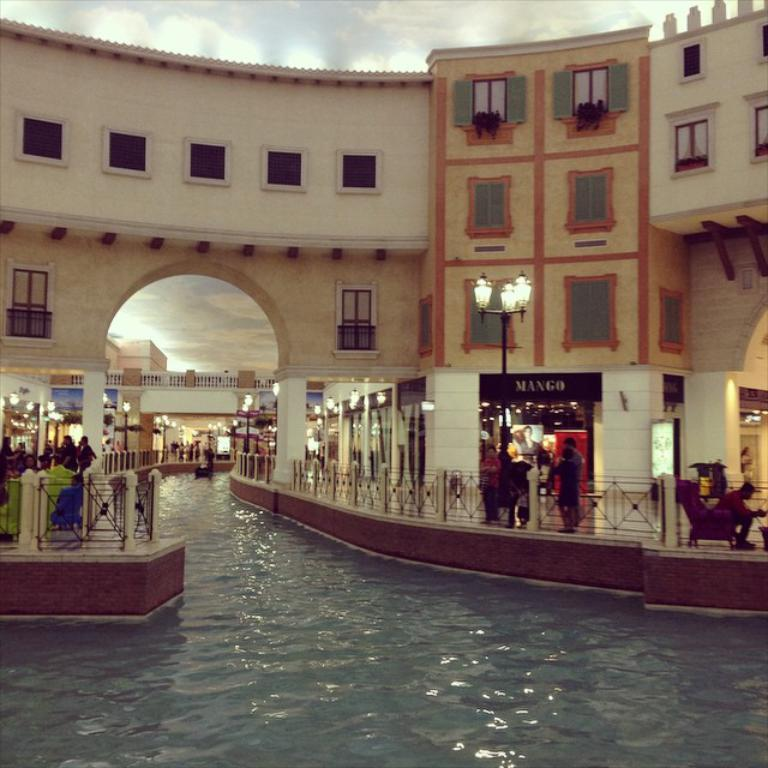What is the main feature in the center of the image? There is water in the center of the image. What structures can be seen in the image? There are fences, stores, and buildings in the image. Who or what is present in the image? People are present in the image. What type of infrastructure is visible in the image? There are light poles in the image. What type of reaction can be seen from the quince in the image? There is no quince present in the image, so no reaction can be observed. How many steps are visible in the image? There is no mention of steps in the provided facts, so we cannot determine the number of steps in the image. 